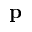<formula> <loc_0><loc_0><loc_500><loc_500>p</formula> 